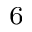Convert formula to latex. <formula><loc_0><loc_0><loc_500><loc_500>_ { 6 }</formula> 